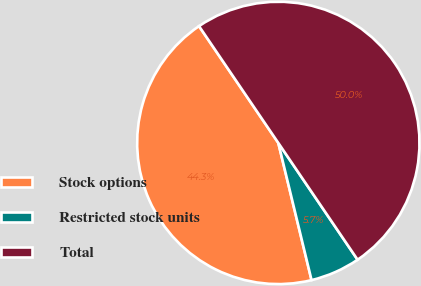<chart> <loc_0><loc_0><loc_500><loc_500><pie_chart><fcel>Stock options<fcel>Restricted stock units<fcel>Total<nl><fcel>44.29%<fcel>5.71%<fcel>50.0%<nl></chart> 